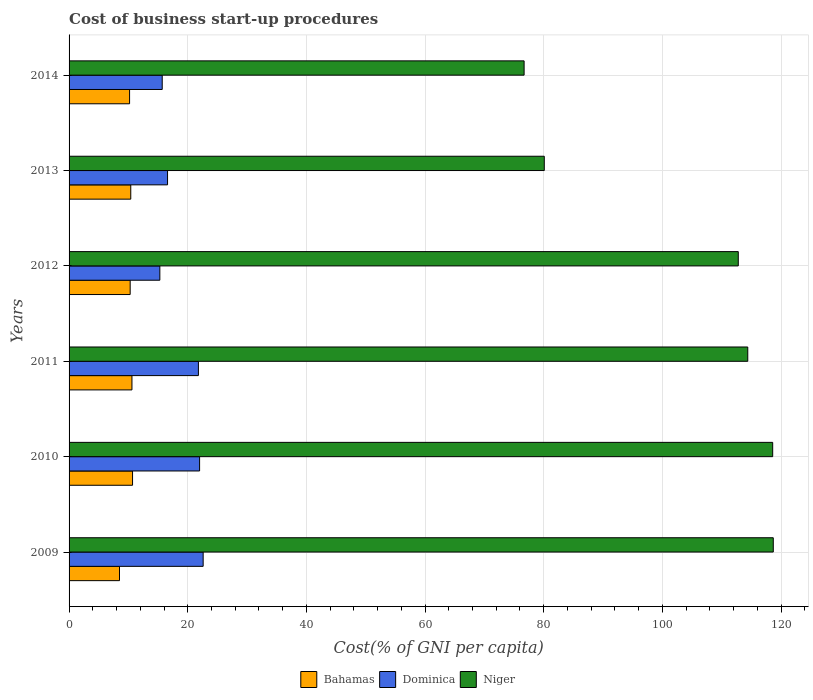Are the number of bars per tick equal to the number of legend labels?
Offer a terse response. Yes. Are the number of bars on each tick of the Y-axis equal?
Your answer should be very brief. Yes. How many bars are there on the 5th tick from the top?
Provide a succinct answer. 3. Across all years, what is the maximum cost of business start-up procedures in Dominica?
Provide a succinct answer. 22.6. Across all years, what is the minimum cost of business start-up procedures in Bahamas?
Keep it short and to the point. 8.5. In which year was the cost of business start-up procedures in Dominica minimum?
Make the answer very short. 2012. What is the total cost of business start-up procedures in Dominica in the graph?
Offer a very short reply. 114. What is the difference between the cost of business start-up procedures in Dominica in 2009 and that in 2013?
Keep it short and to the point. 6. What is the difference between the cost of business start-up procedures in Bahamas in 2013 and the cost of business start-up procedures in Dominica in 2012?
Offer a terse response. -4.9. What is the average cost of business start-up procedures in Niger per year?
Offer a very short reply. 103.55. In the year 2009, what is the difference between the cost of business start-up procedures in Dominica and cost of business start-up procedures in Niger?
Make the answer very short. -96.1. What is the ratio of the cost of business start-up procedures in Niger in 2010 to that in 2012?
Provide a succinct answer. 1.05. Is the cost of business start-up procedures in Niger in 2009 less than that in 2010?
Give a very brief answer. No. What is the difference between the highest and the second highest cost of business start-up procedures in Bahamas?
Keep it short and to the point. 0.1. In how many years, is the cost of business start-up procedures in Bahamas greater than the average cost of business start-up procedures in Bahamas taken over all years?
Provide a succinct answer. 5. Is the sum of the cost of business start-up procedures in Niger in 2009 and 2010 greater than the maximum cost of business start-up procedures in Dominica across all years?
Make the answer very short. Yes. What does the 2nd bar from the top in 2011 represents?
Keep it short and to the point. Dominica. What does the 1st bar from the bottom in 2012 represents?
Your answer should be compact. Bahamas. How many bars are there?
Ensure brevity in your answer.  18. Are all the bars in the graph horizontal?
Offer a very short reply. Yes. How many years are there in the graph?
Provide a short and direct response. 6. What is the difference between two consecutive major ticks on the X-axis?
Keep it short and to the point. 20. Does the graph contain any zero values?
Your response must be concise. No. Does the graph contain grids?
Keep it short and to the point. Yes. What is the title of the graph?
Your response must be concise. Cost of business start-up procedures. What is the label or title of the X-axis?
Your answer should be very brief. Cost(% of GNI per capita). What is the label or title of the Y-axis?
Keep it short and to the point. Years. What is the Cost(% of GNI per capita) of Bahamas in 2009?
Provide a short and direct response. 8.5. What is the Cost(% of GNI per capita) of Dominica in 2009?
Your answer should be compact. 22.6. What is the Cost(% of GNI per capita) of Niger in 2009?
Ensure brevity in your answer.  118.7. What is the Cost(% of GNI per capita) of Niger in 2010?
Your answer should be compact. 118.6. What is the Cost(% of GNI per capita) of Bahamas in 2011?
Make the answer very short. 10.6. What is the Cost(% of GNI per capita) of Dominica in 2011?
Provide a short and direct response. 21.8. What is the Cost(% of GNI per capita) in Niger in 2011?
Make the answer very short. 114.4. What is the Cost(% of GNI per capita) in Bahamas in 2012?
Keep it short and to the point. 10.3. What is the Cost(% of GNI per capita) in Niger in 2012?
Make the answer very short. 112.8. What is the Cost(% of GNI per capita) of Dominica in 2013?
Make the answer very short. 16.6. What is the Cost(% of GNI per capita) of Niger in 2013?
Your answer should be compact. 80.1. What is the Cost(% of GNI per capita) of Niger in 2014?
Your response must be concise. 76.7. Across all years, what is the maximum Cost(% of GNI per capita) in Dominica?
Offer a very short reply. 22.6. Across all years, what is the maximum Cost(% of GNI per capita) in Niger?
Your response must be concise. 118.7. Across all years, what is the minimum Cost(% of GNI per capita) of Dominica?
Your response must be concise. 15.3. Across all years, what is the minimum Cost(% of GNI per capita) in Niger?
Your response must be concise. 76.7. What is the total Cost(% of GNI per capita) in Bahamas in the graph?
Your answer should be compact. 60.7. What is the total Cost(% of GNI per capita) of Dominica in the graph?
Your answer should be very brief. 114. What is the total Cost(% of GNI per capita) in Niger in the graph?
Offer a terse response. 621.3. What is the difference between the Cost(% of GNI per capita) in Bahamas in 2009 and that in 2010?
Keep it short and to the point. -2.2. What is the difference between the Cost(% of GNI per capita) of Niger in 2009 and that in 2010?
Keep it short and to the point. 0.1. What is the difference between the Cost(% of GNI per capita) in Dominica in 2009 and that in 2011?
Ensure brevity in your answer.  0.8. What is the difference between the Cost(% of GNI per capita) of Niger in 2009 and that in 2011?
Your answer should be very brief. 4.3. What is the difference between the Cost(% of GNI per capita) in Bahamas in 2009 and that in 2012?
Your answer should be very brief. -1.8. What is the difference between the Cost(% of GNI per capita) of Dominica in 2009 and that in 2012?
Give a very brief answer. 7.3. What is the difference between the Cost(% of GNI per capita) in Bahamas in 2009 and that in 2013?
Provide a succinct answer. -1.9. What is the difference between the Cost(% of GNI per capita) of Niger in 2009 and that in 2013?
Give a very brief answer. 38.6. What is the difference between the Cost(% of GNI per capita) of Dominica in 2009 and that in 2014?
Provide a succinct answer. 6.9. What is the difference between the Cost(% of GNI per capita) of Niger in 2009 and that in 2014?
Offer a very short reply. 42. What is the difference between the Cost(% of GNI per capita) of Dominica in 2010 and that in 2011?
Your answer should be very brief. 0.2. What is the difference between the Cost(% of GNI per capita) of Bahamas in 2010 and that in 2013?
Your response must be concise. 0.3. What is the difference between the Cost(% of GNI per capita) of Niger in 2010 and that in 2013?
Your answer should be very brief. 38.5. What is the difference between the Cost(% of GNI per capita) of Bahamas in 2010 and that in 2014?
Keep it short and to the point. 0.5. What is the difference between the Cost(% of GNI per capita) in Niger in 2010 and that in 2014?
Ensure brevity in your answer.  41.9. What is the difference between the Cost(% of GNI per capita) of Bahamas in 2011 and that in 2012?
Offer a very short reply. 0.3. What is the difference between the Cost(% of GNI per capita) in Niger in 2011 and that in 2012?
Your response must be concise. 1.6. What is the difference between the Cost(% of GNI per capita) of Bahamas in 2011 and that in 2013?
Your response must be concise. 0.2. What is the difference between the Cost(% of GNI per capita) of Niger in 2011 and that in 2013?
Offer a terse response. 34.3. What is the difference between the Cost(% of GNI per capita) in Bahamas in 2011 and that in 2014?
Offer a very short reply. 0.4. What is the difference between the Cost(% of GNI per capita) in Niger in 2011 and that in 2014?
Your answer should be very brief. 37.7. What is the difference between the Cost(% of GNI per capita) in Bahamas in 2012 and that in 2013?
Provide a succinct answer. -0.1. What is the difference between the Cost(% of GNI per capita) of Dominica in 2012 and that in 2013?
Provide a short and direct response. -1.3. What is the difference between the Cost(% of GNI per capita) in Niger in 2012 and that in 2013?
Your answer should be compact. 32.7. What is the difference between the Cost(% of GNI per capita) of Bahamas in 2012 and that in 2014?
Your answer should be very brief. 0.1. What is the difference between the Cost(% of GNI per capita) in Dominica in 2012 and that in 2014?
Make the answer very short. -0.4. What is the difference between the Cost(% of GNI per capita) of Niger in 2012 and that in 2014?
Offer a very short reply. 36.1. What is the difference between the Cost(% of GNI per capita) of Bahamas in 2013 and that in 2014?
Provide a succinct answer. 0.2. What is the difference between the Cost(% of GNI per capita) in Bahamas in 2009 and the Cost(% of GNI per capita) in Dominica in 2010?
Your answer should be very brief. -13.5. What is the difference between the Cost(% of GNI per capita) of Bahamas in 2009 and the Cost(% of GNI per capita) of Niger in 2010?
Your response must be concise. -110.1. What is the difference between the Cost(% of GNI per capita) of Dominica in 2009 and the Cost(% of GNI per capita) of Niger in 2010?
Keep it short and to the point. -96. What is the difference between the Cost(% of GNI per capita) of Bahamas in 2009 and the Cost(% of GNI per capita) of Niger in 2011?
Offer a very short reply. -105.9. What is the difference between the Cost(% of GNI per capita) in Dominica in 2009 and the Cost(% of GNI per capita) in Niger in 2011?
Your answer should be very brief. -91.8. What is the difference between the Cost(% of GNI per capita) in Bahamas in 2009 and the Cost(% of GNI per capita) in Niger in 2012?
Your answer should be very brief. -104.3. What is the difference between the Cost(% of GNI per capita) of Dominica in 2009 and the Cost(% of GNI per capita) of Niger in 2012?
Your answer should be compact. -90.2. What is the difference between the Cost(% of GNI per capita) in Bahamas in 2009 and the Cost(% of GNI per capita) in Dominica in 2013?
Ensure brevity in your answer.  -8.1. What is the difference between the Cost(% of GNI per capita) of Bahamas in 2009 and the Cost(% of GNI per capita) of Niger in 2013?
Ensure brevity in your answer.  -71.6. What is the difference between the Cost(% of GNI per capita) in Dominica in 2009 and the Cost(% of GNI per capita) in Niger in 2013?
Make the answer very short. -57.5. What is the difference between the Cost(% of GNI per capita) of Bahamas in 2009 and the Cost(% of GNI per capita) of Niger in 2014?
Your answer should be very brief. -68.2. What is the difference between the Cost(% of GNI per capita) of Dominica in 2009 and the Cost(% of GNI per capita) of Niger in 2014?
Provide a short and direct response. -54.1. What is the difference between the Cost(% of GNI per capita) of Bahamas in 2010 and the Cost(% of GNI per capita) of Niger in 2011?
Provide a succinct answer. -103.7. What is the difference between the Cost(% of GNI per capita) of Dominica in 2010 and the Cost(% of GNI per capita) of Niger in 2011?
Ensure brevity in your answer.  -92.4. What is the difference between the Cost(% of GNI per capita) of Bahamas in 2010 and the Cost(% of GNI per capita) of Niger in 2012?
Your answer should be very brief. -102.1. What is the difference between the Cost(% of GNI per capita) of Dominica in 2010 and the Cost(% of GNI per capita) of Niger in 2012?
Offer a very short reply. -90.8. What is the difference between the Cost(% of GNI per capita) of Bahamas in 2010 and the Cost(% of GNI per capita) of Dominica in 2013?
Ensure brevity in your answer.  -5.9. What is the difference between the Cost(% of GNI per capita) in Bahamas in 2010 and the Cost(% of GNI per capita) in Niger in 2013?
Your answer should be very brief. -69.4. What is the difference between the Cost(% of GNI per capita) of Dominica in 2010 and the Cost(% of GNI per capita) of Niger in 2013?
Keep it short and to the point. -58.1. What is the difference between the Cost(% of GNI per capita) of Bahamas in 2010 and the Cost(% of GNI per capita) of Niger in 2014?
Provide a short and direct response. -66. What is the difference between the Cost(% of GNI per capita) in Dominica in 2010 and the Cost(% of GNI per capita) in Niger in 2014?
Your answer should be very brief. -54.7. What is the difference between the Cost(% of GNI per capita) of Bahamas in 2011 and the Cost(% of GNI per capita) of Dominica in 2012?
Provide a short and direct response. -4.7. What is the difference between the Cost(% of GNI per capita) of Bahamas in 2011 and the Cost(% of GNI per capita) of Niger in 2012?
Provide a succinct answer. -102.2. What is the difference between the Cost(% of GNI per capita) of Dominica in 2011 and the Cost(% of GNI per capita) of Niger in 2012?
Your response must be concise. -91. What is the difference between the Cost(% of GNI per capita) of Bahamas in 2011 and the Cost(% of GNI per capita) of Niger in 2013?
Your response must be concise. -69.5. What is the difference between the Cost(% of GNI per capita) of Dominica in 2011 and the Cost(% of GNI per capita) of Niger in 2013?
Provide a succinct answer. -58.3. What is the difference between the Cost(% of GNI per capita) in Bahamas in 2011 and the Cost(% of GNI per capita) in Dominica in 2014?
Your response must be concise. -5.1. What is the difference between the Cost(% of GNI per capita) of Bahamas in 2011 and the Cost(% of GNI per capita) of Niger in 2014?
Your answer should be very brief. -66.1. What is the difference between the Cost(% of GNI per capita) in Dominica in 2011 and the Cost(% of GNI per capita) in Niger in 2014?
Offer a terse response. -54.9. What is the difference between the Cost(% of GNI per capita) in Bahamas in 2012 and the Cost(% of GNI per capita) in Dominica in 2013?
Give a very brief answer. -6.3. What is the difference between the Cost(% of GNI per capita) of Bahamas in 2012 and the Cost(% of GNI per capita) of Niger in 2013?
Keep it short and to the point. -69.8. What is the difference between the Cost(% of GNI per capita) in Dominica in 2012 and the Cost(% of GNI per capita) in Niger in 2013?
Offer a very short reply. -64.8. What is the difference between the Cost(% of GNI per capita) in Bahamas in 2012 and the Cost(% of GNI per capita) in Dominica in 2014?
Your answer should be very brief. -5.4. What is the difference between the Cost(% of GNI per capita) of Bahamas in 2012 and the Cost(% of GNI per capita) of Niger in 2014?
Offer a very short reply. -66.4. What is the difference between the Cost(% of GNI per capita) of Dominica in 2012 and the Cost(% of GNI per capita) of Niger in 2014?
Offer a very short reply. -61.4. What is the difference between the Cost(% of GNI per capita) in Bahamas in 2013 and the Cost(% of GNI per capita) in Niger in 2014?
Your answer should be very brief. -66.3. What is the difference between the Cost(% of GNI per capita) in Dominica in 2013 and the Cost(% of GNI per capita) in Niger in 2014?
Ensure brevity in your answer.  -60.1. What is the average Cost(% of GNI per capita) in Bahamas per year?
Keep it short and to the point. 10.12. What is the average Cost(% of GNI per capita) of Dominica per year?
Keep it short and to the point. 19. What is the average Cost(% of GNI per capita) of Niger per year?
Your answer should be compact. 103.55. In the year 2009, what is the difference between the Cost(% of GNI per capita) in Bahamas and Cost(% of GNI per capita) in Dominica?
Give a very brief answer. -14.1. In the year 2009, what is the difference between the Cost(% of GNI per capita) of Bahamas and Cost(% of GNI per capita) of Niger?
Your answer should be very brief. -110.2. In the year 2009, what is the difference between the Cost(% of GNI per capita) in Dominica and Cost(% of GNI per capita) in Niger?
Your answer should be very brief. -96.1. In the year 2010, what is the difference between the Cost(% of GNI per capita) in Bahamas and Cost(% of GNI per capita) in Niger?
Provide a short and direct response. -107.9. In the year 2010, what is the difference between the Cost(% of GNI per capita) in Dominica and Cost(% of GNI per capita) in Niger?
Ensure brevity in your answer.  -96.6. In the year 2011, what is the difference between the Cost(% of GNI per capita) in Bahamas and Cost(% of GNI per capita) in Dominica?
Make the answer very short. -11.2. In the year 2011, what is the difference between the Cost(% of GNI per capita) in Bahamas and Cost(% of GNI per capita) in Niger?
Keep it short and to the point. -103.8. In the year 2011, what is the difference between the Cost(% of GNI per capita) in Dominica and Cost(% of GNI per capita) in Niger?
Your response must be concise. -92.6. In the year 2012, what is the difference between the Cost(% of GNI per capita) of Bahamas and Cost(% of GNI per capita) of Dominica?
Your answer should be very brief. -5. In the year 2012, what is the difference between the Cost(% of GNI per capita) in Bahamas and Cost(% of GNI per capita) in Niger?
Provide a short and direct response. -102.5. In the year 2012, what is the difference between the Cost(% of GNI per capita) in Dominica and Cost(% of GNI per capita) in Niger?
Provide a succinct answer. -97.5. In the year 2013, what is the difference between the Cost(% of GNI per capita) in Bahamas and Cost(% of GNI per capita) in Niger?
Offer a very short reply. -69.7. In the year 2013, what is the difference between the Cost(% of GNI per capita) in Dominica and Cost(% of GNI per capita) in Niger?
Offer a very short reply. -63.5. In the year 2014, what is the difference between the Cost(% of GNI per capita) of Bahamas and Cost(% of GNI per capita) of Dominica?
Your answer should be compact. -5.5. In the year 2014, what is the difference between the Cost(% of GNI per capita) of Bahamas and Cost(% of GNI per capita) of Niger?
Your answer should be compact. -66.5. In the year 2014, what is the difference between the Cost(% of GNI per capita) of Dominica and Cost(% of GNI per capita) of Niger?
Your answer should be very brief. -61. What is the ratio of the Cost(% of GNI per capita) of Bahamas in 2009 to that in 2010?
Offer a very short reply. 0.79. What is the ratio of the Cost(% of GNI per capita) in Dominica in 2009 to that in 2010?
Keep it short and to the point. 1.03. What is the ratio of the Cost(% of GNI per capita) in Bahamas in 2009 to that in 2011?
Keep it short and to the point. 0.8. What is the ratio of the Cost(% of GNI per capita) of Dominica in 2009 to that in 2011?
Ensure brevity in your answer.  1.04. What is the ratio of the Cost(% of GNI per capita) in Niger in 2009 to that in 2011?
Ensure brevity in your answer.  1.04. What is the ratio of the Cost(% of GNI per capita) of Bahamas in 2009 to that in 2012?
Your answer should be very brief. 0.83. What is the ratio of the Cost(% of GNI per capita) in Dominica in 2009 to that in 2012?
Ensure brevity in your answer.  1.48. What is the ratio of the Cost(% of GNI per capita) of Niger in 2009 to that in 2012?
Give a very brief answer. 1.05. What is the ratio of the Cost(% of GNI per capita) of Bahamas in 2009 to that in 2013?
Offer a terse response. 0.82. What is the ratio of the Cost(% of GNI per capita) of Dominica in 2009 to that in 2013?
Give a very brief answer. 1.36. What is the ratio of the Cost(% of GNI per capita) of Niger in 2009 to that in 2013?
Offer a terse response. 1.48. What is the ratio of the Cost(% of GNI per capita) of Bahamas in 2009 to that in 2014?
Give a very brief answer. 0.83. What is the ratio of the Cost(% of GNI per capita) of Dominica in 2009 to that in 2014?
Your answer should be compact. 1.44. What is the ratio of the Cost(% of GNI per capita) of Niger in 2009 to that in 2014?
Your response must be concise. 1.55. What is the ratio of the Cost(% of GNI per capita) in Bahamas in 2010 to that in 2011?
Provide a short and direct response. 1.01. What is the ratio of the Cost(% of GNI per capita) of Dominica in 2010 to that in 2011?
Keep it short and to the point. 1.01. What is the ratio of the Cost(% of GNI per capita) in Niger in 2010 to that in 2011?
Provide a short and direct response. 1.04. What is the ratio of the Cost(% of GNI per capita) in Bahamas in 2010 to that in 2012?
Provide a short and direct response. 1.04. What is the ratio of the Cost(% of GNI per capita) of Dominica in 2010 to that in 2012?
Give a very brief answer. 1.44. What is the ratio of the Cost(% of GNI per capita) of Niger in 2010 to that in 2012?
Your response must be concise. 1.05. What is the ratio of the Cost(% of GNI per capita) in Bahamas in 2010 to that in 2013?
Ensure brevity in your answer.  1.03. What is the ratio of the Cost(% of GNI per capita) of Dominica in 2010 to that in 2013?
Keep it short and to the point. 1.33. What is the ratio of the Cost(% of GNI per capita) of Niger in 2010 to that in 2013?
Offer a very short reply. 1.48. What is the ratio of the Cost(% of GNI per capita) in Bahamas in 2010 to that in 2014?
Your answer should be compact. 1.05. What is the ratio of the Cost(% of GNI per capita) in Dominica in 2010 to that in 2014?
Ensure brevity in your answer.  1.4. What is the ratio of the Cost(% of GNI per capita) of Niger in 2010 to that in 2014?
Give a very brief answer. 1.55. What is the ratio of the Cost(% of GNI per capita) in Bahamas in 2011 to that in 2012?
Your answer should be compact. 1.03. What is the ratio of the Cost(% of GNI per capita) in Dominica in 2011 to that in 2012?
Offer a very short reply. 1.42. What is the ratio of the Cost(% of GNI per capita) in Niger in 2011 to that in 2012?
Keep it short and to the point. 1.01. What is the ratio of the Cost(% of GNI per capita) in Bahamas in 2011 to that in 2013?
Give a very brief answer. 1.02. What is the ratio of the Cost(% of GNI per capita) of Dominica in 2011 to that in 2013?
Provide a succinct answer. 1.31. What is the ratio of the Cost(% of GNI per capita) of Niger in 2011 to that in 2013?
Your response must be concise. 1.43. What is the ratio of the Cost(% of GNI per capita) in Bahamas in 2011 to that in 2014?
Your response must be concise. 1.04. What is the ratio of the Cost(% of GNI per capita) of Dominica in 2011 to that in 2014?
Your answer should be compact. 1.39. What is the ratio of the Cost(% of GNI per capita) of Niger in 2011 to that in 2014?
Your answer should be compact. 1.49. What is the ratio of the Cost(% of GNI per capita) in Dominica in 2012 to that in 2013?
Your response must be concise. 0.92. What is the ratio of the Cost(% of GNI per capita) of Niger in 2012 to that in 2013?
Provide a succinct answer. 1.41. What is the ratio of the Cost(% of GNI per capita) of Bahamas in 2012 to that in 2014?
Your response must be concise. 1.01. What is the ratio of the Cost(% of GNI per capita) of Dominica in 2012 to that in 2014?
Keep it short and to the point. 0.97. What is the ratio of the Cost(% of GNI per capita) in Niger in 2012 to that in 2014?
Provide a short and direct response. 1.47. What is the ratio of the Cost(% of GNI per capita) in Bahamas in 2013 to that in 2014?
Your answer should be compact. 1.02. What is the ratio of the Cost(% of GNI per capita) in Dominica in 2013 to that in 2014?
Ensure brevity in your answer.  1.06. What is the ratio of the Cost(% of GNI per capita) in Niger in 2013 to that in 2014?
Your response must be concise. 1.04. What is the difference between the highest and the second highest Cost(% of GNI per capita) of Bahamas?
Provide a short and direct response. 0.1. What is the difference between the highest and the second highest Cost(% of GNI per capita) in Dominica?
Offer a terse response. 0.6. What is the difference between the highest and the lowest Cost(% of GNI per capita) of Niger?
Your answer should be compact. 42. 